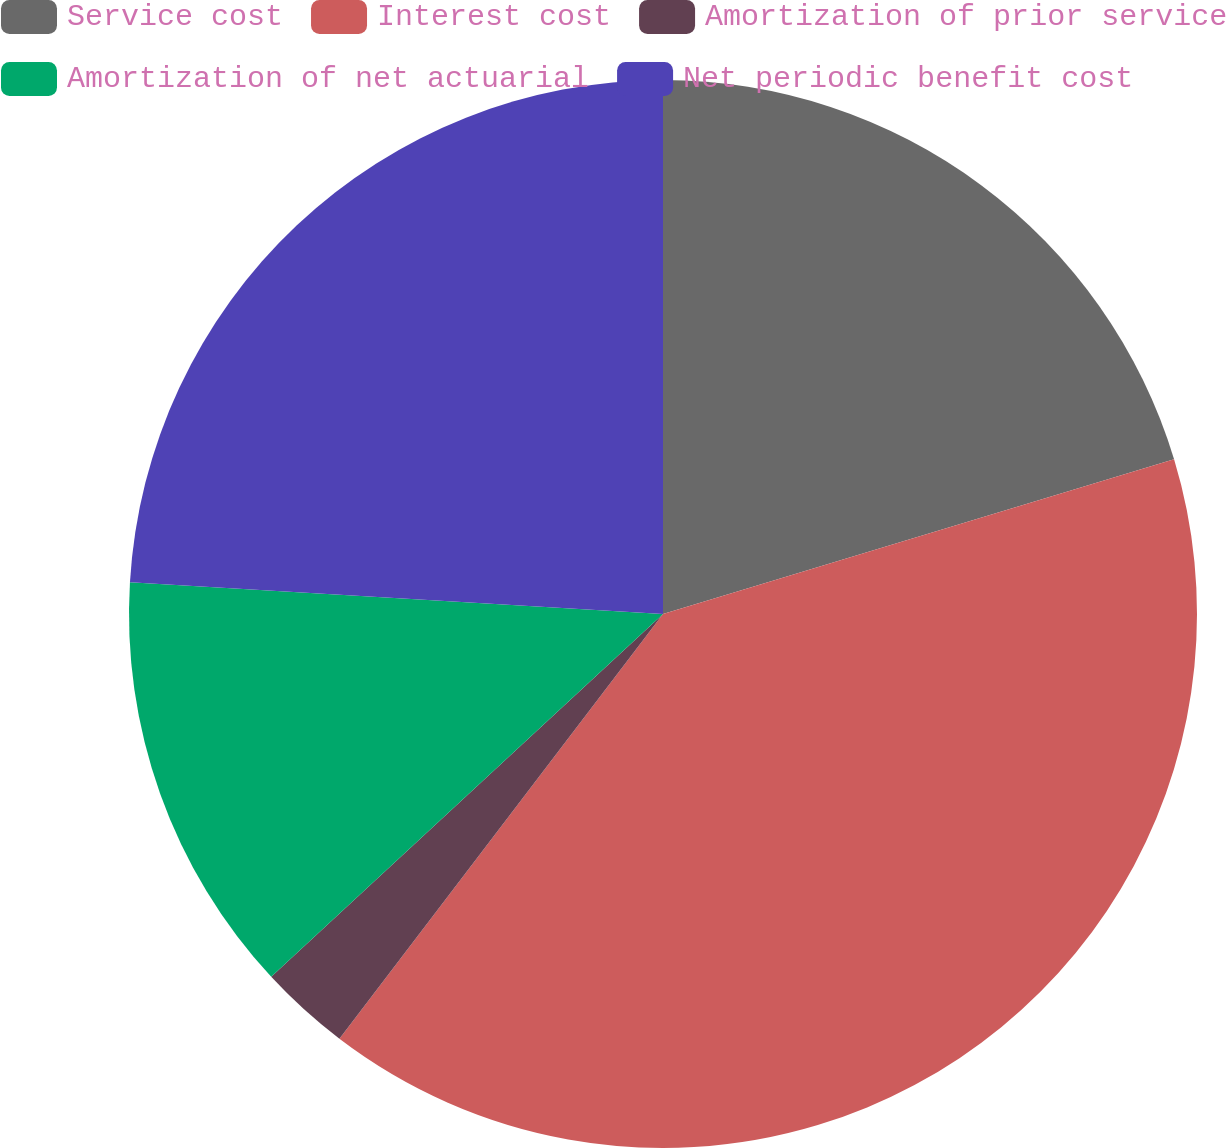<chart> <loc_0><loc_0><loc_500><loc_500><pie_chart><fcel>Service cost<fcel>Interest cost<fcel>Amortization of prior service<fcel>Amortization of net actuarial<fcel>Net periodic benefit cost<nl><fcel>20.32%<fcel>40.04%<fcel>2.75%<fcel>12.84%<fcel>24.05%<nl></chart> 